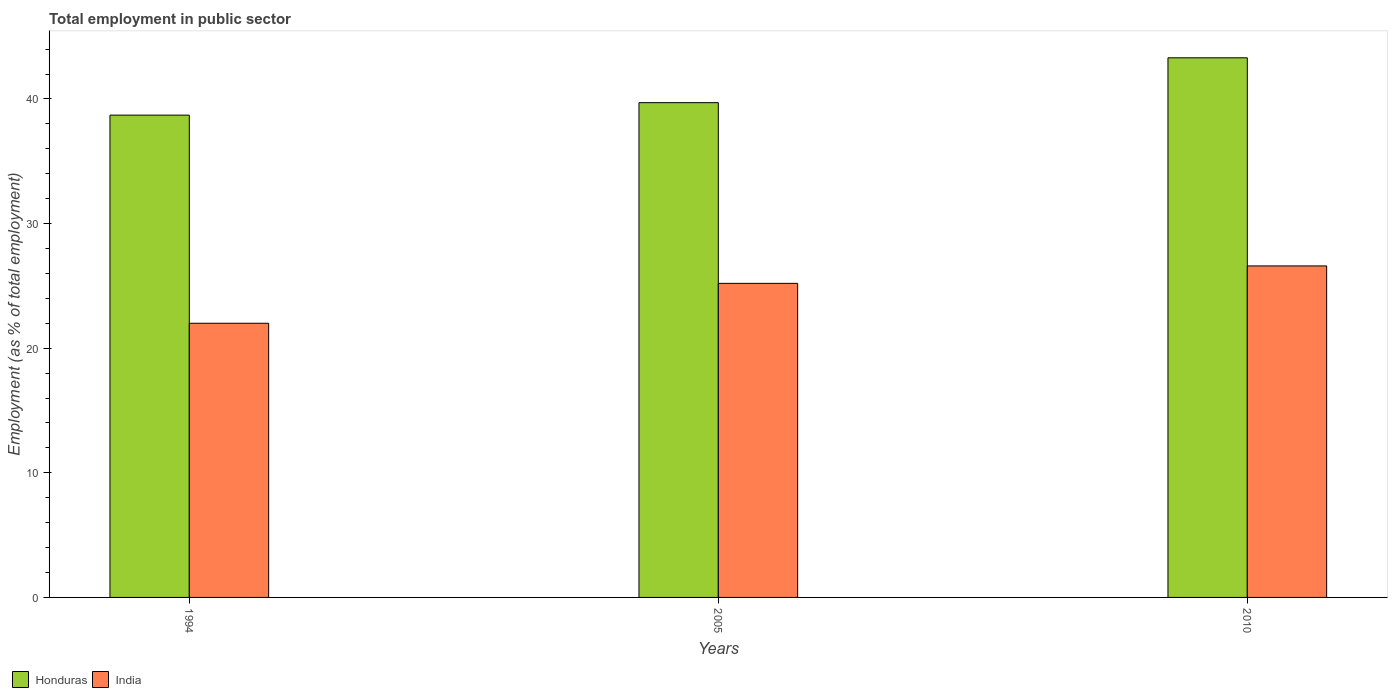How many groups of bars are there?
Offer a terse response. 3. Are the number of bars per tick equal to the number of legend labels?
Your response must be concise. Yes. Are the number of bars on each tick of the X-axis equal?
Offer a very short reply. Yes. How many bars are there on the 3rd tick from the left?
Your answer should be compact. 2. How many bars are there on the 3rd tick from the right?
Make the answer very short. 2. What is the label of the 2nd group of bars from the left?
Your answer should be compact. 2005. In how many cases, is the number of bars for a given year not equal to the number of legend labels?
Your response must be concise. 0. Across all years, what is the maximum employment in public sector in India?
Offer a very short reply. 26.6. Across all years, what is the minimum employment in public sector in Honduras?
Ensure brevity in your answer.  38.7. In which year was the employment in public sector in India maximum?
Your response must be concise. 2010. What is the total employment in public sector in India in the graph?
Offer a very short reply. 73.8. What is the difference between the employment in public sector in Honduras in 2005 and that in 2010?
Offer a terse response. -3.6. What is the difference between the employment in public sector in Honduras in 2010 and the employment in public sector in India in 1994?
Your answer should be compact. 21.3. What is the average employment in public sector in India per year?
Keep it short and to the point. 24.6. In the year 2010, what is the difference between the employment in public sector in Honduras and employment in public sector in India?
Your answer should be very brief. 16.7. In how many years, is the employment in public sector in India greater than 12 %?
Provide a short and direct response. 3. What is the ratio of the employment in public sector in Honduras in 2005 to that in 2010?
Keep it short and to the point. 0.92. Is the employment in public sector in India in 1994 less than that in 2010?
Ensure brevity in your answer.  Yes. What is the difference between the highest and the second highest employment in public sector in Honduras?
Offer a terse response. 3.6. What is the difference between the highest and the lowest employment in public sector in India?
Offer a terse response. 4.6. In how many years, is the employment in public sector in Honduras greater than the average employment in public sector in Honduras taken over all years?
Keep it short and to the point. 1. Is the sum of the employment in public sector in India in 1994 and 2010 greater than the maximum employment in public sector in Honduras across all years?
Make the answer very short. Yes. Are all the bars in the graph horizontal?
Your answer should be very brief. No. How many years are there in the graph?
Offer a very short reply. 3. Are the values on the major ticks of Y-axis written in scientific E-notation?
Offer a very short reply. No. Does the graph contain any zero values?
Your answer should be compact. No. Does the graph contain grids?
Keep it short and to the point. No. How many legend labels are there?
Your answer should be compact. 2. What is the title of the graph?
Your answer should be compact. Total employment in public sector. Does "India" appear as one of the legend labels in the graph?
Provide a short and direct response. Yes. What is the label or title of the X-axis?
Your response must be concise. Years. What is the label or title of the Y-axis?
Your response must be concise. Employment (as % of total employment). What is the Employment (as % of total employment) in Honduras in 1994?
Give a very brief answer. 38.7. What is the Employment (as % of total employment) of India in 1994?
Make the answer very short. 22. What is the Employment (as % of total employment) of Honduras in 2005?
Provide a short and direct response. 39.7. What is the Employment (as % of total employment) in India in 2005?
Give a very brief answer. 25.2. What is the Employment (as % of total employment) of Honduras in 2010?
Your response must be concise. 43.3. What is the Employment (as % of total employment) in India in 2010?
Provide a short and direct response. 26.6. Across all years, what is the maximum Employment (as % of total employment) in Honduras?
Give a very brief answer. 43.3. Across all years, what is the maximum Employment (as % of total employment) in India?
Give a very brief answer. 26.6. Across all years, what is the minimum Employment (as % of total employment) of Honduras?
Offer a very short reply. 38.7. Across all years, what is the minimum Employment (as % of total employment) in India?
Your answer should be compact. 22. What is the total Employment (as % of total employment) in Honduras in the graph?
Provide a succinct answer. 121.7. What is the total Employment (as % of total employment) in India in the graph?
Your answer should be compact. 73.8. What is the difference between the Employment (as % of total employment) in Honduras in 1994 and that in 2005?
Offer a very short reply. -1. What is the difference between the Employment (as % of total employment) of India in 1994 and that in 2005?
Provide a short and direct response. -3.2. What is the difference between the Employment (as % of total employment) in Honduras in 1994 and that in 2010?
Offer a terse response. -4.6. What is the difference between the Employment (as % of total employment) in Honduras in 2005 and that in 2010?
Offer a terse response. -3.6. What is the difference between the Employment (as % of total employment) of Honduras in 1994 and the Employment (as % of total employment) of India in 2005?
Make the answer very short. 13.5. What is the difference between the Employment (as % of total employment) in Honduras in 1994 and the Employment (as % of total employment) in India in 2010?
Your answer should be very brief. 12.1. What is the average Employment (as % of total employment) of Honduras per year?
Make the answer very short. 40.57. What is the average Employment (as % of total employment) in India per year?
Offer a terse response. 24.6. What is the ratio of the Employment (as % of total employment) of Honduras in 1994 to that in 2005?
Offer a very short reply. 0.97. What is the ratio of the Employment (as % of total employment) of India in 1994 to that in 2005?
Make the answer very short. 0.87. What is the ratio of the Employment (as % of total employment) of Honduras in 1994 to that in 2010?
Provide a short and direct response. 0.89. What is the ratio of the Employment (as % of total employment) in India in 1994 to that in 2010?
Your answer should be compact. 0.83. What is the ratio of the Employment (as % of total employment) of Honduras in 2005 to that in 2010?
Give a very brief answer. 0.92. What is the ratio of the Employment (as % of total employment) in India in 2005 to that in 2010?
Your answer should be compact. 0.95. What is the difference between the highest and the second highest Employment (as % of total employment) of Honduras?
Ensure brevity in your answer.  3.6. What is the difference between the highest and the second highest Employment (as % of total employment) of India?
Your answer should be very brief. 1.4. What is the difference between the highest and the lowest Employment (as % of total employment) in Honduras?
Your answer should be very brief. 4.6. 